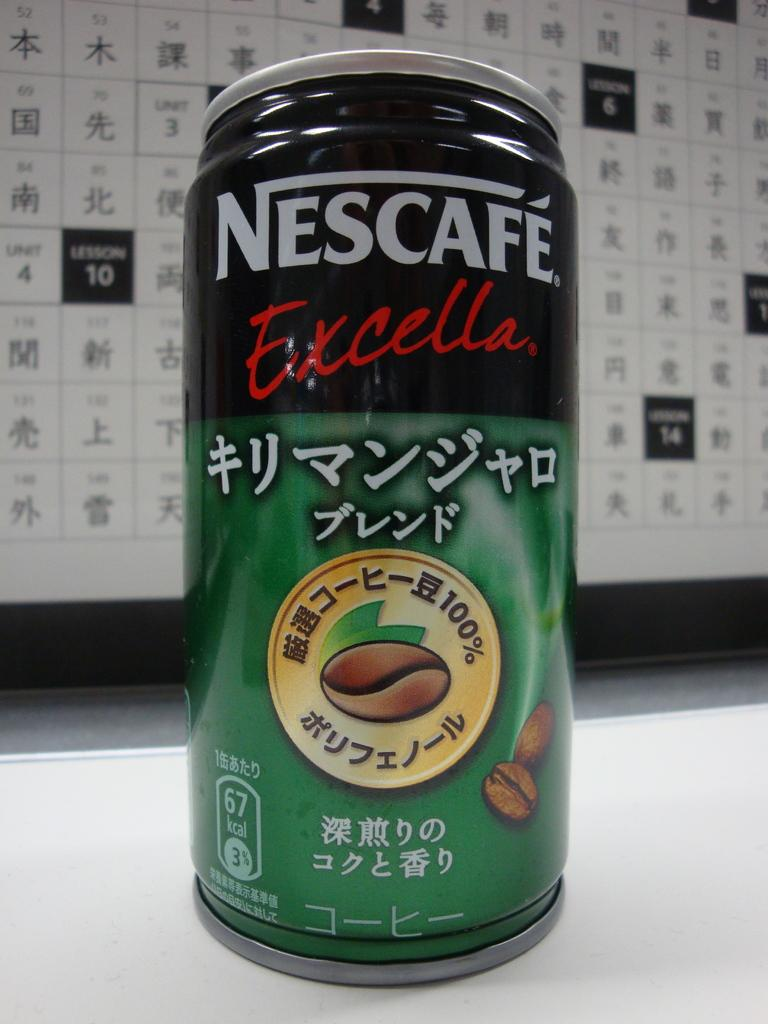<image>
Offer a succinct explanation of the picture presented. The green can of Nescafe Excella has a black band around the top and an emblem with a coffee bean in it. 